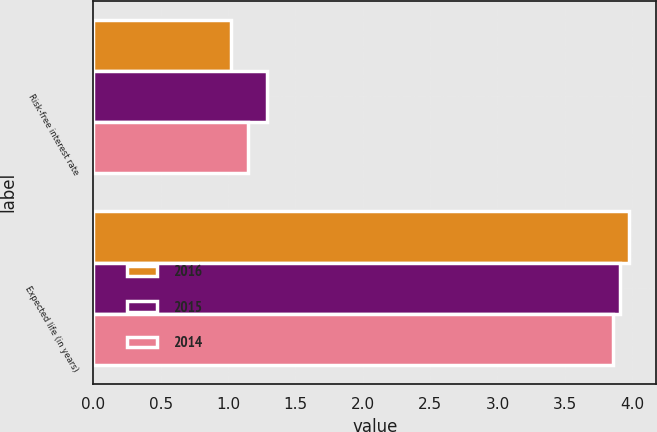Convert chart. <chart><loc_0><loc_0><loc_500><loc_500><stacked_bar_chart><ecel><fcel>Risk-free interest rate<fcel>Expected life (in years)<nl><fcel>2016<fcel>1.02<fcel>3.98<nl><fcel>2015<fcel>1.29<fcel>3.91<nl><fcel>2014<fcel>1.15<fcel>3.86<nl></chart> 